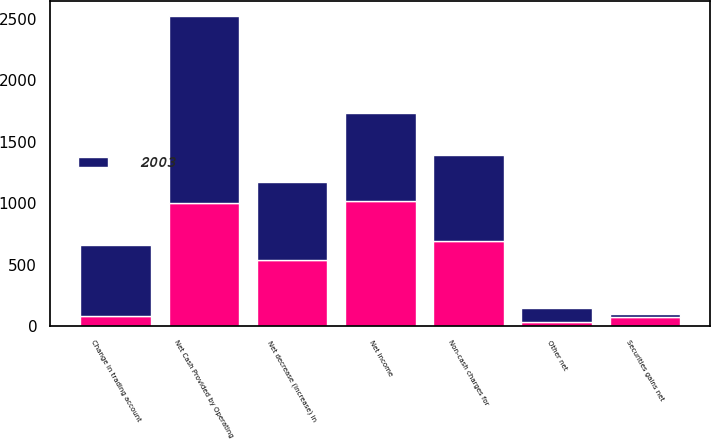Convert chart to OTSL. <chart><loc_0><loc_0><loc_500><loc_500><stacked_bar_chart><ecel><fcel>Net income<fcel>Non-cash charges for<fcel>Securities gains net<fcel>Change in trading account<fcel>Other net<fcel>Net Cash Provided by Operating<fcel>Net decrease (increase) in<nl><fcel>2003<fcel>722<fcel>701<fcel>23<fcel>579<fcel>117<fcel>1517<fcel>635.5<nl><fcel>nan<fcel>1015<fcel>692<fcel>76<fcel>80<fcel>34<fcel>1002<fcel>535<nl></chart> 